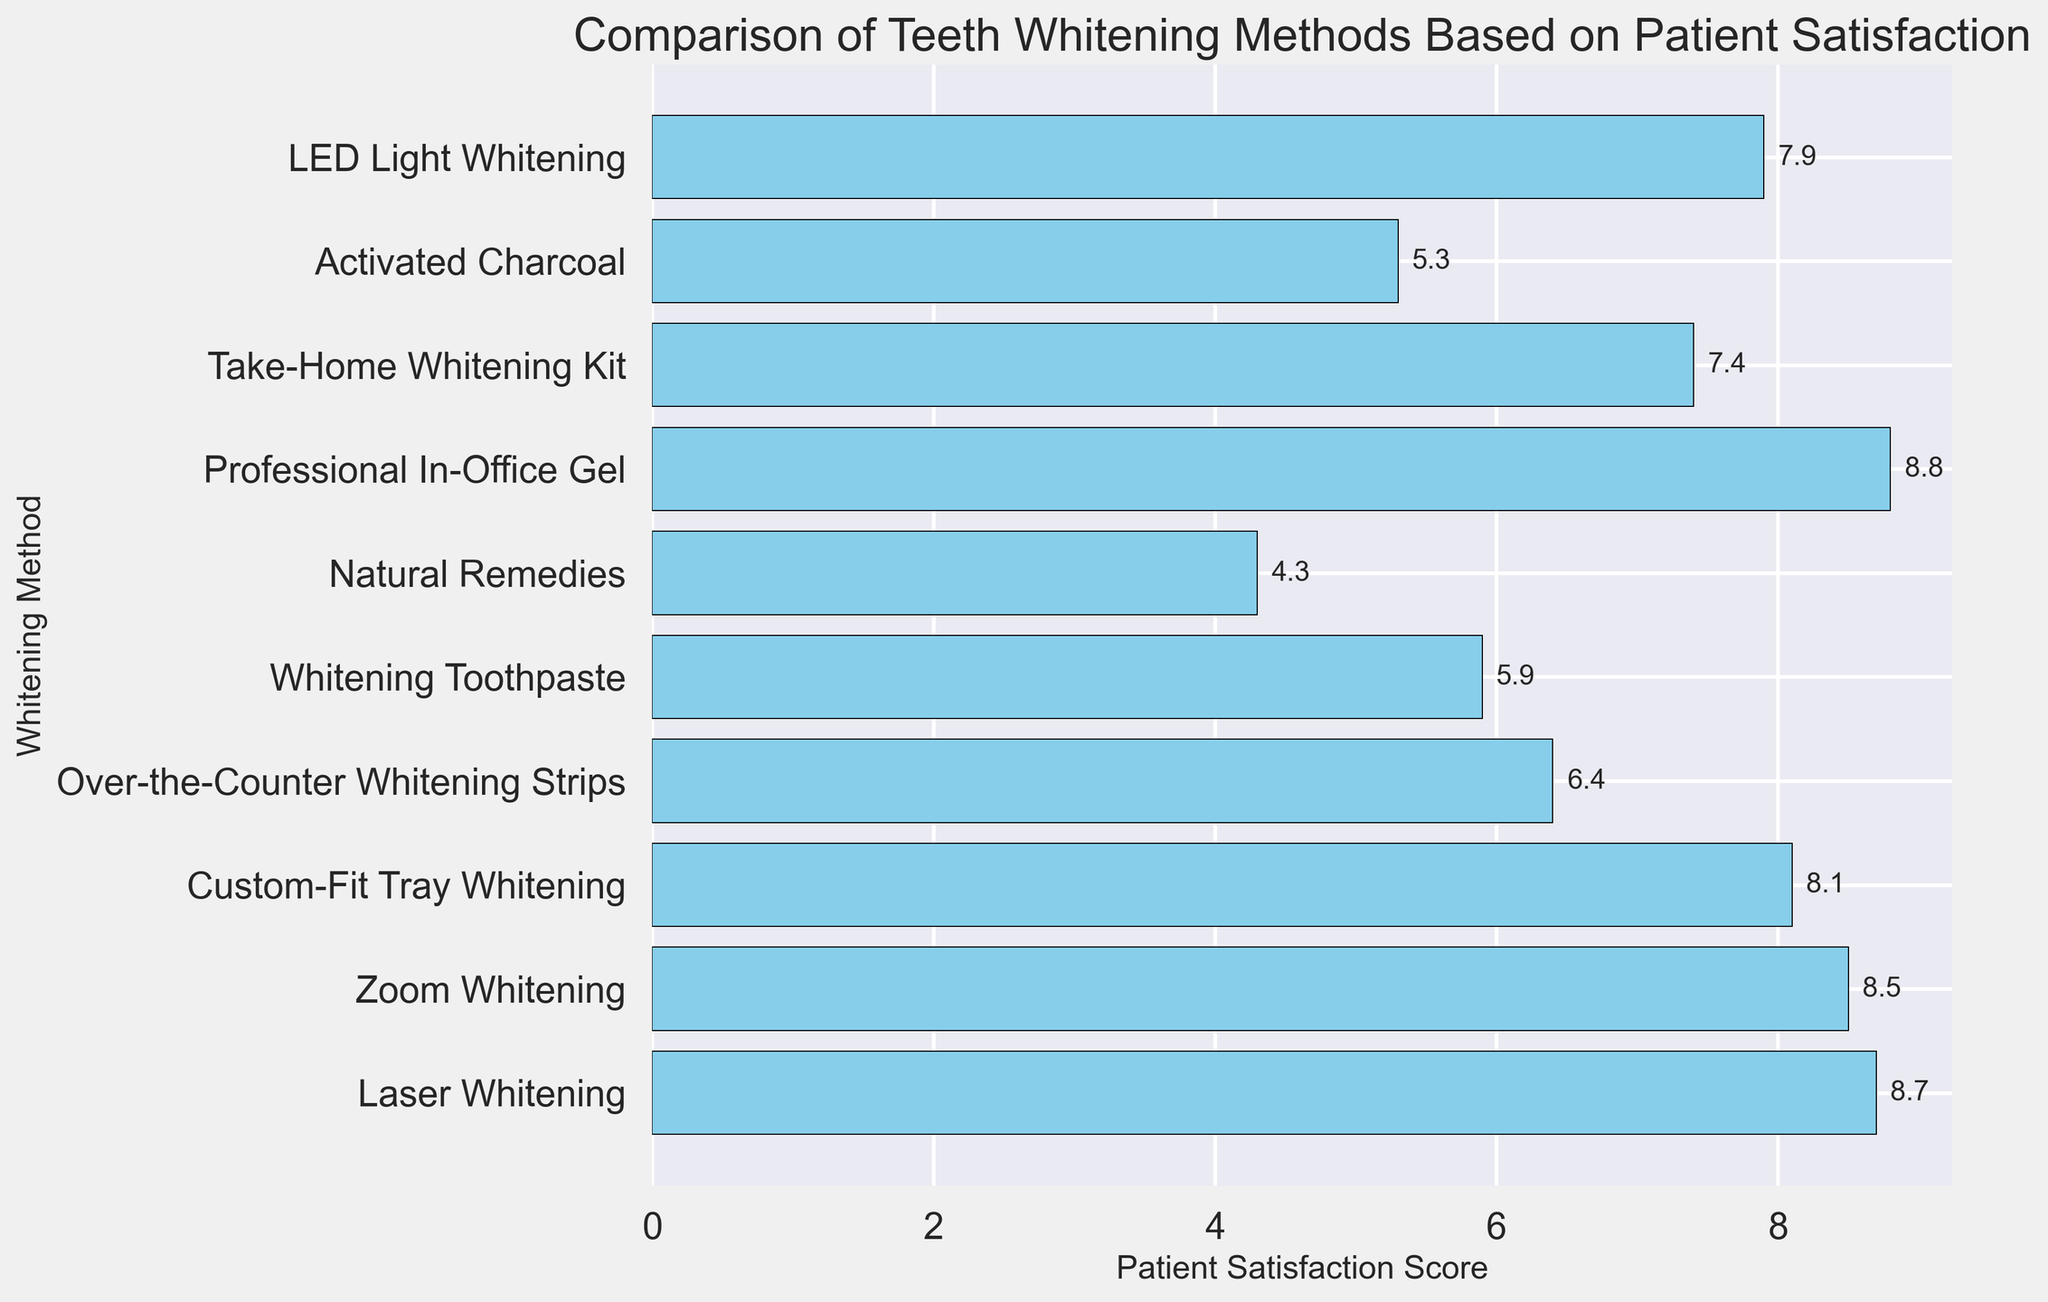Which teeth whitening method has the highest patient satisfaction score? We look for the method with the longest bar in the chart. The "Professional In-Office Gel" has the highest score.
Answer: Professional In-Office Gel How much higher is the patient satisfaction score for Laser Whitening than Activated Charcoal? We find the scores of Laser Whitening (8.7) and Activated Charcoal (5.3), then subtract: 8.7 - 5.3.
Answer: 3.4 Which methods have a patient satisfaction score greater than 8? We scan for bars with scores above 8: Laser Whitening, Zoom Whitening, Custom-Fit Tray Whitening, and Professional In-Office Gel.
Answer: Laser Whitening, Zoom Whitening, Custom-Fit Tray Whitening, Professional In-Office Gel What is the average satisfaction score of all the methods combined? Sum all the scores and divide by the number of methods: (8.7 + 8.5 + 8.1 + 6.4 + 5.9 + 4.3 + 8.8 + 7.4 + 5.3 + 7.9) / 10. The sum is 71.3, divide by 10.
Answer: 7.13 Is the patient satisfaction score of LED Light Whitening closer to Custom-Fit Tray Whitening or Take-Home Whitening Kit? Compare differences: LED Light Whitening (7.9) with Custom-Fit Tray Whitening (8.1) and Take-Home Whitening Kit (7.4). Differences: 8.1 - 7.9 = 0.2 and 7.9 - 7.4 = 0.5. Closer score is with Custom-Fit Tray Whitening.
Answer: Custom-Fit Tray Whitening What is the total difference in patient satisfaction score between the highest and lowest scoring methods? Identify the highest score (Professional In-Office Gel at 8.8) and lowest score (Natural Remedies at 4.3), then subtract: 8.8 - 4.3.
Answer: 4.5 Which method has a slightly lower score than Zoom Whitening? Zoom Whitening has a score of 8.5. The method with a slightly lower score is Custom-Fit Tray Whitening at 8.1.
Answer: Custom-Fit Tray Whitening 